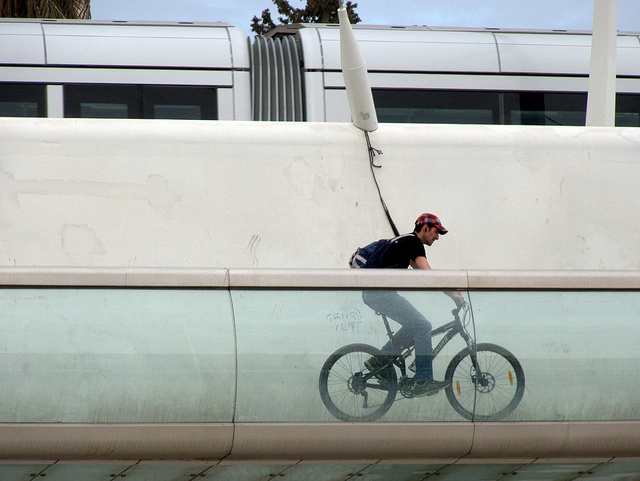Describe the objects in this image and their specific colors. I can see train in black, lightgray, darkgray, and gray tones, bicycle in black, darkgray, gray, and purple tones, people in black, gray, darkgray, and purple tones, and backpack in black, lightgray, darkgray, and navy tones in this image. 